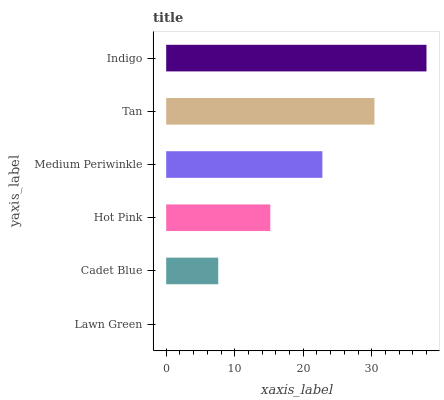Is Lawn Green the minimum?
Answer yes or no. Yes. Is Indigo the maximum?
Answer yes or no. Yes. Is Cadet Blue the minimum?
Answer yes or no. No. Is Cadet Blue the maximum?
Answer yes or no. No. Is Cadet Blue greater than Lawn Green?
Answer yes or no. Yes. Is Lawn Green less than Cadet Blue?
Answer yes or no. Yes. Is Lawn Green greater than Cadet Blue?
Answer yes or no. No. Is Cadet Blue less than Lawn Green?
Answer yes or no. No. Is Medium Periwinkle the high median?
Answer yes or no. Yes. Is Hot Pink the low median?
Answer yes or no. Yes. Is Cadet Blue the high median?
Answer yes or no. No. Is Tan the low median?
Answer yes or no. No. 